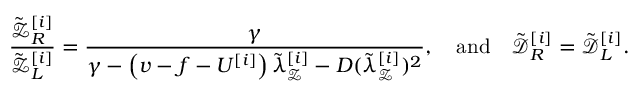<formula> <loc_0><loc_0><loc_500><loc_500>\frac { \tilde { \mathcal { Z } } _ { R } ^ { [ i ] } } { \tilde { \mathcal { Z } } _ { L } ^ { [ i ] } } = \frac { \gamma } { \gamma - \left ( v - f - U ^ { [ i ] } \right ) \tilde { \lambda } _ { \mathcal { Z } } ^ { [ i ] } - D ( \tilde { \lambda } _ { \mathcal { Z } } ^ { [ i ] } ) ^ { 2 } } , \quad a n d \quad \tilde { \mathcal { D } } _ { R } ^ { [ i ] } = \tilde { \mathcal { D } } _ { L } ^ { [ i ] } .</formula> 